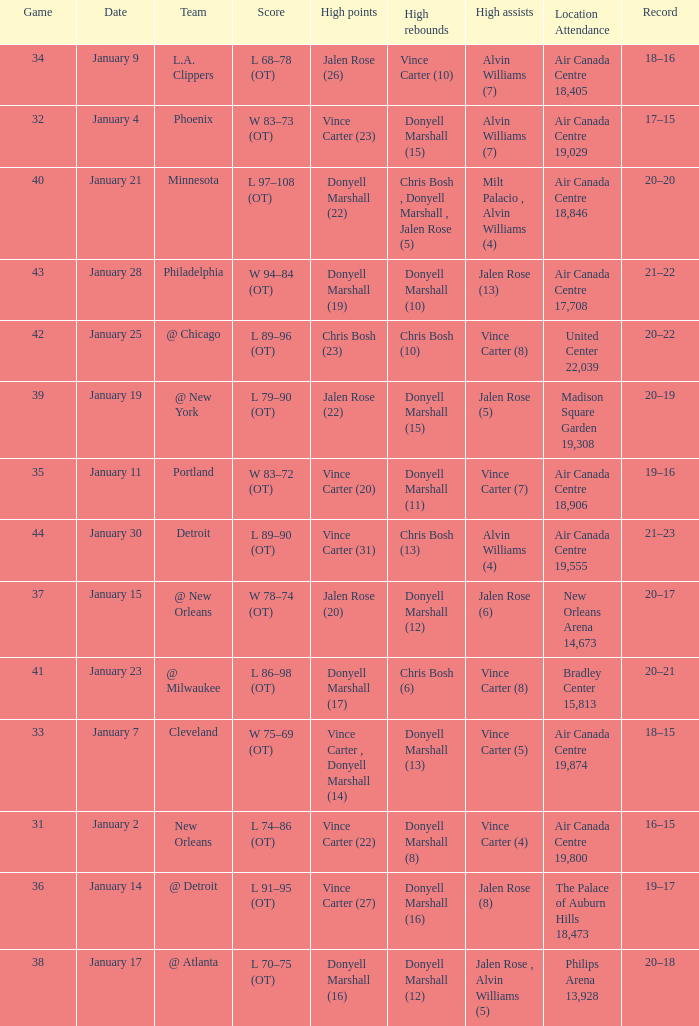What is the Location and Attendance with a Record of 21–22? Air Canada Centre 17,708. 